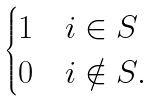Convert formula to latex. <formula><loc_0><loc_0><loc_500><loc_500>\begin{cases} 1 & i \in S \\ 0 & i \notin S . \end{cases}</formula> 